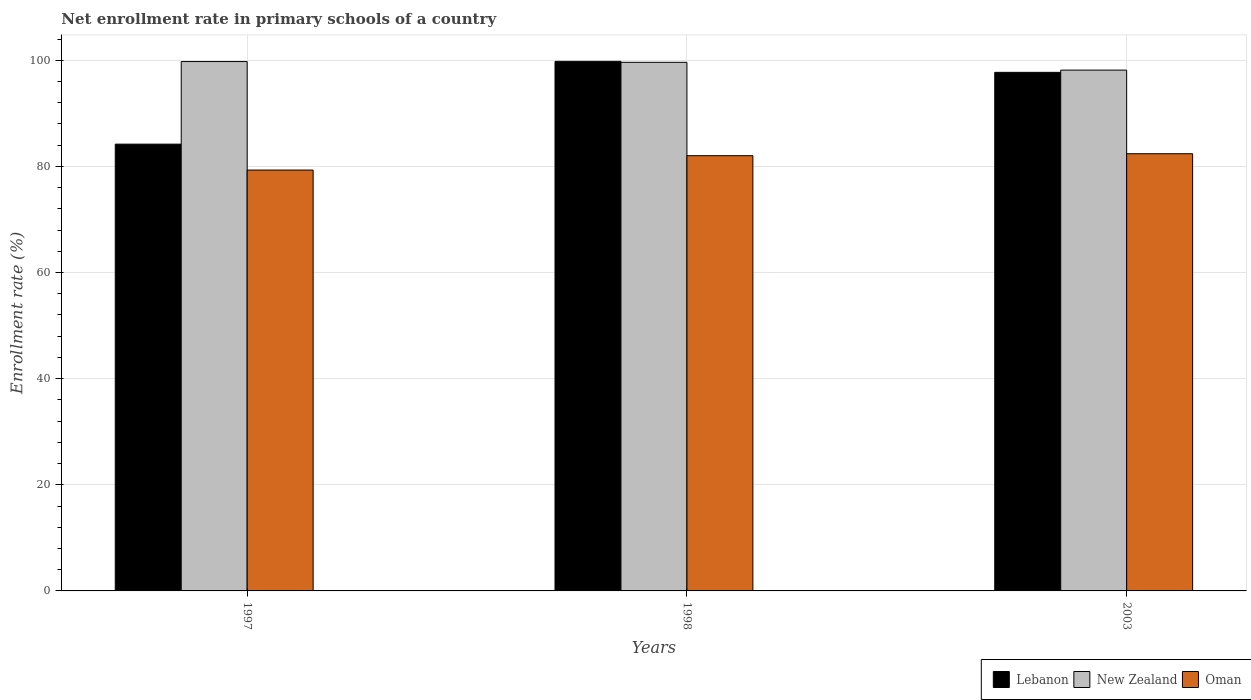How many different coloured bars are there?
Your answer should be very brief. 3. How many groups of bars are there?
Provide a succinct answer. 3. Are the number of bars on each tick of the X-axis equal?
Your response must be concise. Yes. How many bars are there on the 1st tick from the right?
Keep it short and to the point. 3. What is the label of the 3rd group of bars from the left?
Your response must be concise. 2003. What is the enrollment rate in primary schools in Lebanon in 1997?
Your answer should be compact. 84.19. Across all years, what is the maximum enrollment rate in primary schools in Lebanon?
Provide a short and direct response. 99.8. Across all years, what is the minimum enrollment rate in primary schools in Oman?
Offer a terse response. 79.31. What is the total enrollment rate in primary schools in Lebanon in the graph?
Your answer should be compact. 281.71. What is the difference between the enrollment rate in primary schools in Lebanon in 1997 and that in 1998?
Provide a succinct answer. -15.6. What is the difference between the enrollment rate in primary schools in Oman in 2003 and the enrollment rate in primary schools in New Zealand in 1997?
Keep it short and to the point. -17.37. What is the average enrollment rate in primary schools in Lebanon per year?
Ensure brevity in your answer.  93.9. In the year 1997, what is the difference between the enrollment rate in primary schools in Oman and enrollment rate in primary schools in Lebanon?
Offer a terse response. -4.88. In how many years, is the enrollment rate in primary schools in Oman greater than 92 %?
Provide a succinct answer. 0. What is the ratio of the enrollment rate in primary schools in Lebanon in 1998 to that in 2003?
Offer a very short reply. 1.02. Is the difference between the enrollment rate in primary schools in Oman in 1997 and 2003 greater than the difference between the enrollment rate in primary schools in Lebanon in 1997 and 2003?
Offer a terse response. Yes. What is the difference between the highest and the second highest enrollment rate in primary schools in New Zealand?
Give a very brief answer. 0.15. What is the difference between the highest and the lowest enrollment rate in primary schools in Lebanon?
Offer a very short reply. 15.6. In how many years, is the enrollment rate in primary schools in Lebanon greater than the average enrollment rate in primary schools in Lebanon taken over all years?
Your response must be concise. 2. Is the sum of the enrollment rate in primary schools in Lebanon in 1997 and 2003 greater than the maximum enrollment rate in primary schools in Oman across all years?
Your response must be concise. Yes. What does the 3rd bar from the left in 2003 represents?
Give a very brief answer. Oman. What does the 3rd bar from the right in 2003 represents?
Ensure brevity in your answer.  Lebanon. How many bars are there?
Your answer should be very brief. 9. Are all the bars in the graph horizontal?
Your answer should be compact. No. How many years are there in the graph?
Provide a short and direct response. 3. What is the difference between two consecutive major ticks on the Y-axis?
Keep it short and to the point. 20. Where does the legend appear in the graph?
Your answer should be compact. Bottom right. How are the legend labels stacked?
Keep it short and to the point. Horizontal. What is the title of the graph?
Your answer should be very brief. Net enrollment rate in primary schools of a country. What is the label or title of the Y-axis?
Keep it short and to the point. Enrollment rate (%). What is the Enrollment rate (%) in Lebanon in 1997?
Your answer should be compact. 84.19. What is the Enrollment rate (%) of New Zealand in 1997?
Provide a succinct answer. 99.76. What is the Enrollment rate (%) in Oman in 1997?
Offer a very short reply. 79.31. What is the Enrollment rate (%) in Lebanon in 1998?
Keep it short and to the point. 99.8. What is the Enrollment rate (%) of New Zealand in 1998?
Offer a terse response. 99.61. What is the Enrollment rate (%) of Oman in 1998?
Make the answer very short. 82.02. What is the Enrollment rate (%) in Lebanon in 2003?
Make the answer very short. 97.72. What is the Enrollment rate (%) in New Zealand in 2003?
Make the answer very short. 98.14. What is the Enrollment rate (%) of Oman in 2003?
Make the answer very short. 82.39. Across all years, what is the maximum Enrollment rate (%) in Lebanon?
Give a very brief answer. 99.8. Across all years, what is the maximum Enrollment rate (%) of New Zealand?
Your answer should be very brief. 99.76. Across all years, what is the maximum Enrollment rate (%) of Oman?
Your response must be concise. 82.39. Across all years, what is the minimum Enrollment rate (%) in Lebanon?
Make the answer very short. 84.19. Across all years, what is the minimum Enrollment rate (%) of New Zealand?
Offer a very short reply. 98.14. Across all years, what is the minimum Enrollment rate (%) in Oman?
Make the answer very short. 79.31. What is the total Enrollment rate (%) in Lebanon in the graph?
Make the answer very short. 281.71. What is the total Enrollment rate (%) of New Zealand in the graph?
Keep it short and to the point. 297.51. What is the total Enrollment rate (%) in Oman in the graph?
Offer a very short reply. 243.72. What is the difference between the Enrollment rate (%) of Lebanon in 1997 and that in 1998?
Your response must be concise. -15.6. What is the difference between the Enrollment rate (%) in New Zealand in 1997 and that in 1998?
Provide a succinct answer. 0.15. What is the difference between the Enrollment rate (%) of Oman in 1997 and that in 1998?
Give a very brief answer. -2.71. What is the difference between the Enrollment rate (%) in Lebanon in 1997 and that in 2003?
Your response must be concise. -13.53. What is the difference between the Enrollment rate (%) in New Zealand in 1997 and that in 2003?
Keep it short and to the point. 1.61. What is the difference between the Enrollment rate (%) in Oman in 1997 and that in 2003?
Provide a succinct answer. -3.08. What is the difference between the Enrollment rate (%) of Lebanon in 1998 and that in 2003?
Offer a terse response. 2.07. What is the difference between the Enrollment rate (%) of New Zealand in 1998 and that in 2003?
Offer a very short reply. 1.47. What is the difference between the Enrollment rate (%) of Oman in 1998 and that in 2003?
Ensure brevity in your answer.  -0.37. What is the difference between the Enrollment rate (%) of Lebanon in 1997 and the Enrollment rate (%) of New Zealand in 1998?
Provide a succinct answer. -15.42. What is the difference between the Enrollment rate (%) in Lebanon in 1997 and the Enrollment rate (%) in Oman in 1998?
Offer a terse response. 2.18. What is the difference between the Enrollment rate (%) of New Zealand in 1997 and the Enrollment rate (%) of Oman in 1998?
Provide a short and direct response. 17.74. What is the difference between the Enrollment rate (%) in Lebanon in 1997 and the Enrollment rate (%) in New Zealand in 2003?
Your answer should be very brief. -13.95. What is the difference between the Enrollment rate (%) of Lebanon in 1997 and the Enrollment rate (%) of Oman in 2003?
Offer a very short reply. 1.81. What is the difference between the Enrollment rate (%) in New Zealand in 1997 and the Enrollment rate (%) in Oman in 2003?
Provide a succinct answer. 17.37. What is the difference between the Enrollment rate (%) in Lebanon in 1998 and the Enrollment rate (%) in New Zealand in 2003?
Your answer should be very brief. 1.65. What is the difference between the Enrollment rate (%) of Lebanon in 1998 and the Enrollment rate (%) of Oman in 2003?
Ensure brevity in your answer.  17.41. What is the difference between the Enrollment rate (%) of New Zealand in 1998 and the Enrollment rate (%) of Oman in 2003?
Ensure brevity in your answer.  17.22. What is the average Enrollment rate (%) of Lebanon per year?
Make the answer very short. 93.9. What is the average Enrollment rate (%) in New Zealand per year?
Offer a terse response. 99.17. What is the average Enrollment rate (%) in Oman per year?
Ensure brevity in your answer.  81.24. In the year 1997, what is the difference between the Enrollment rate (%) in Lebanon and Enrollment rate (%) in New Zealand?
Your answer should be very brief. -15.56. In the year 1997, what is the difference between the Enrollment rate (%) in Lebanon and Enrollment rate (%) in Oman?
Keep it short and to the point. 4.88. In the year 1997, what is the difference between the Enrollment rate (%) in New Zealand and Enrollment rate (%) in Oman?
Your response must be concise. 20.45. In the year 1998, what is the difference between the Enrollment rate (%) in Lebanon and Enrollment rate (%) in New Zealand?
Your answer should be very brief. 0.18. In the year 1998, what is the difference between the Enrollment rate (%) of Lebanon and Enrollment rate (%) of Oman?
Offer a terse response. 17.78. In the year 1998, what is the difference between the Enrollment rate (%) of New Zealand and Enrollment rate (%) of Oman?
Make the answer very short. 17.59. In the year 2003, what is the difference between the Enrollment rate (%) in Lebanon and Enrollment rate (%) in New Zealand?
Your response must be concise. -0.42. In the year 2003, what is the difference between the Enrollment rate (%) in Lebanon and Enrollment rate (%) in Oman?
Offer a terse response. 15.34. In the year 2003, what is the difference between the Enrollment rate (%) in New Zealand and Enrollment rate (%) in Oman?
Keep it short and to the point. 15.76. What is the ratio of the Enrollment rate (%) in Lebanon in 1997 to that in 1998?
Offer a terse response. 0.84. What is the ratio of the Enrollment rate (%) of New Zealand in 1997 to that in 1998?
Give a very brief answer. 1. What is the ratio of the Enrollment rate (%) of Oman in 1997 to that in 1998?
Your answer should be very brief. 0.97. What is the ratio of the Enrollment rate (%) in Lebanon in 1997 to that in 2003?
Make the answer very short. 0.86. What is the ratio of the Enrollment rate (%) of New Zealand in 1997 to that in 2003?
Ensure brevity in your answer.  1.02. What is the ratio of the Enrollment rate (%) of Oman in 1997 to that in 2003?
Your answer should be compact. 0.96. What is the ratio of the Enrollment rate (%) in Lebanon in 1998 to that in 2003?
Provide a succinct answer. 1.02. What is the difference between the highest and the second highest Enrollment rate (%) of Lebanon?
Provide a short and direct response. 2.07. What is the difference between the highest and the second highest Enrollment rate (%) in New Zealand?
Offer a very short reply. 0.15. What is the difference between the highest and the second highest Enrollment rate (%) of Oman?
Provide a short and direct response. 0.37. What is the difference between the highest and the lowest Enrollment rate (%) in Lebanon?
Give a very brief answer. 15.6. What is the difference between the highest and the lowest Enrollment rate (%) in New Zealand?
Keep it short and to the point. 1.61. What is the difference between the highest and the lowest Enrollment rate (%) in Oman?
Provide a short and direct response. 3.08. 